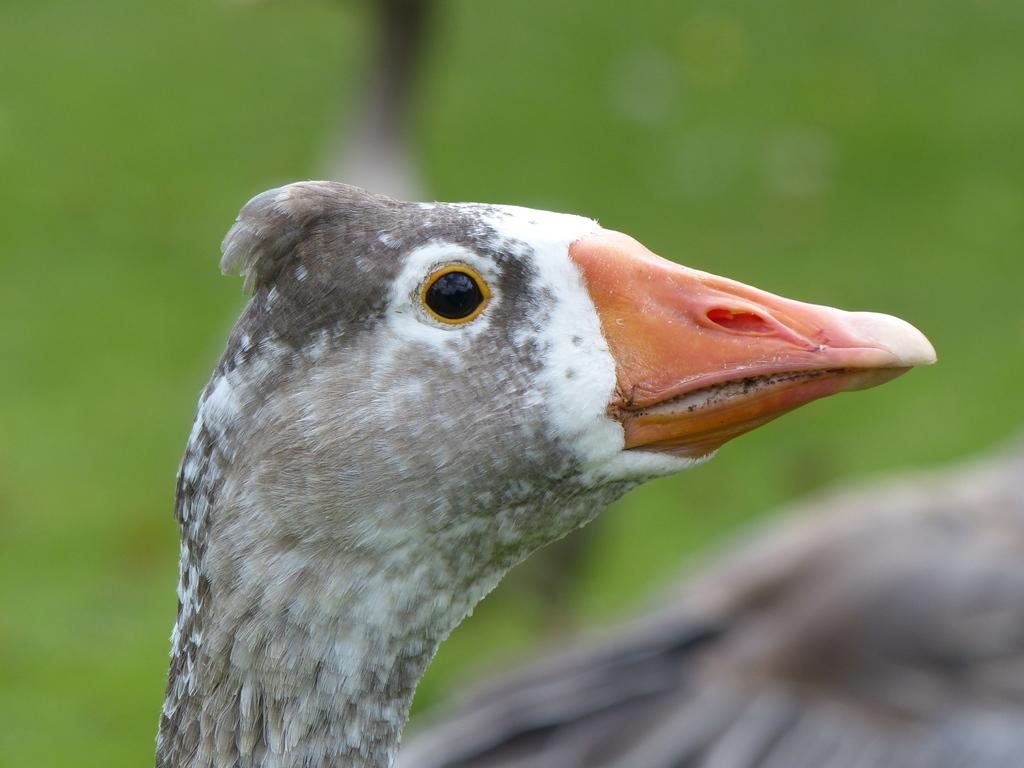What type of bird is in the image? There is a white and grey color bird in the image. Where is the bird located in the image? The bird is in the front of the image. What color is predominant in the background of the image? There is green color in the background of the image. How would you describe the clarity of the image? The image is a little bit blurry. What type of impulse is the bird experiencing in the image? There is no indication of any impulse experienced by the bird in the image. Can you see any bubbles around the bird in the image? There are no bubbles present in the image. 